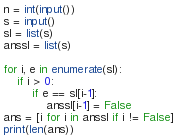<code> <loc_0><loc_0><loc_500><loc_500><_Python_>n = int(input())
s = input()
sl = list(s)
anssl = list(s)

for i, e in enumerate(sl):
    if i > 0:
        if e == sl[i-1]:
            anssl[i-1] = False
ans = [i for i in anssl if i != False]
print(len(ans))</code> 